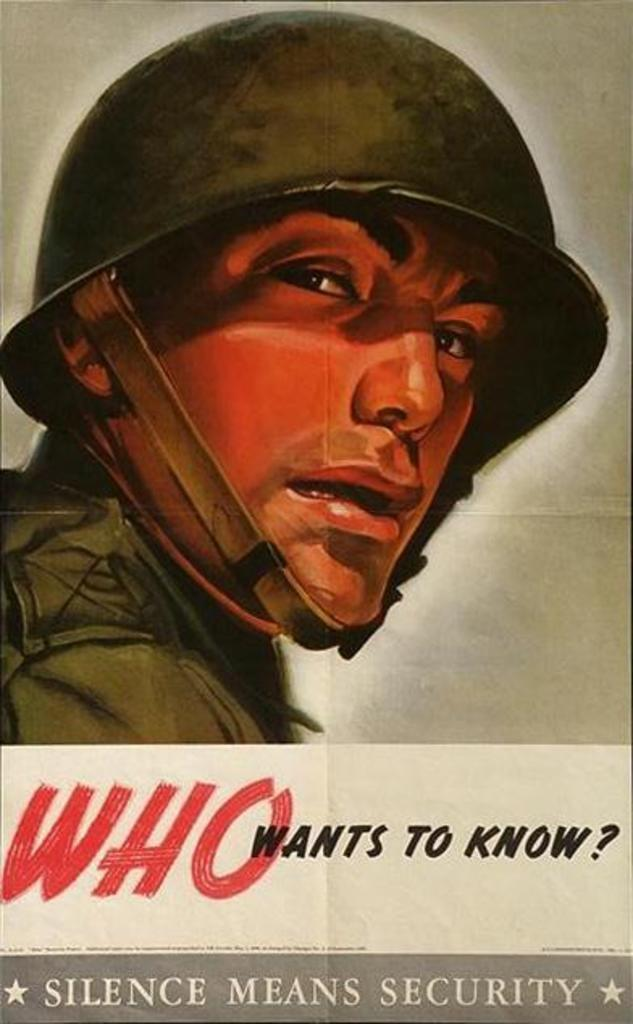Provide a one-sentence caption for the provided image. a poster of a soldier reads Who wants to know. 